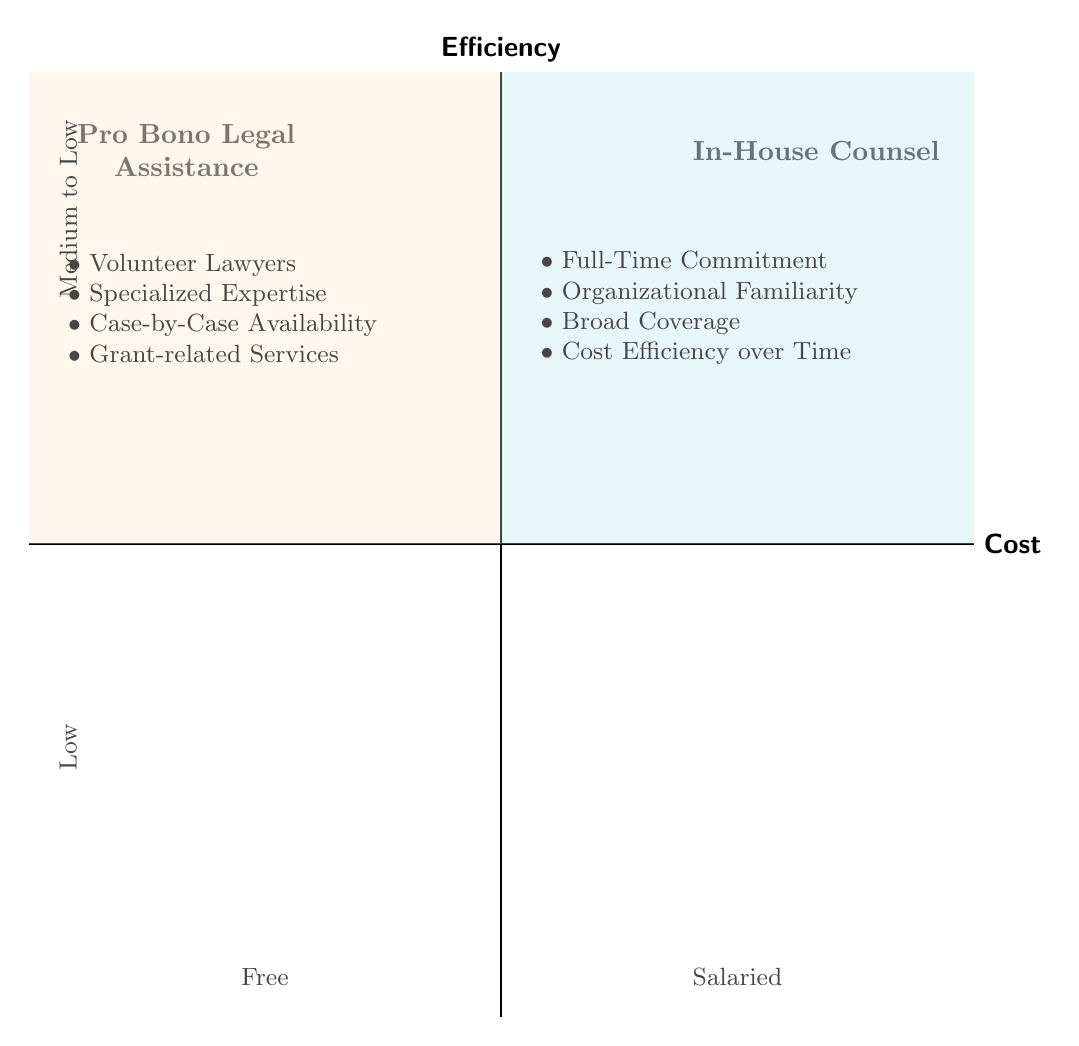What is the cost associated with Pro Bono Legal Assistance? The diagram indicates that the cost associated with Pro Bono Legal Assistance is "Free." This can be found in the quadrant labeled "Pro Bono Legal Assistance," specifically at the position where the vertical axis (Cost) is designated.
Answer: Free How many elements are listed under In-House Counsel? The diagram shows four elements listed under the "In-House Counsel" quadrant. I counted the bullet points, which directly represent each element in that section.
Answer: Four What type of Legal Assistance offers "Case-by-Case Availability"? "Case-by-Case Availability" is mentioned as an element in the "Pro Bono Legal Assistance" quadrant, specifically under its list of elements.
Answer: Pro Bono Legal Assistance Which quadrant is labeled "High" for Efficiency? The "In-House Counsel" quadrant is labeled "High" on the Efficiency axis at the top section of the diagram, indicating this quadrant's efficiency level.
Answer: In-House Counsel Which quadrant discusses "Cost Efficiency over Time"? The element "Cost Efficiency over Time" is listed in the "In-House Counsel" quadrant, making it clear that this aspect pertains to the In-House Counsel's efficiency related to costs.
Answer: In-House Counsel What is the relationship between "Organizational Familiarity" and "Efficiency"? "Organizational Familiarity" is part of the elements in the "In-House Counsel" quadrant, which is marked "High" for Efficiency. This indicates that it contributes positively to overall efficiency.
Answer: Positive How does the cost of Pro Bono compare to In-House Counsel? The cost of Pro Bono Legal Assistance is "Free," while the cost of In-House Counsel is marked as "Salaried." This comparison illustrates that Pro Bono is without direct cost, whereas In-House incurs a salary expense.
Answer: Pro Bono is Free; In-House Counsel is Salaried What describes the availability of Pro Bono Legal Assistance? The availability of Pro Bono Legal Assistance is described as "Case-by-Case Availability", indicating that the assistance is contingent on the volunteers' schedules and commitments.
Answer: Case-by-Case Availability Which element is related to specialized expertise in the Pro Bono quadrant? The element related to specialized expertise in the Pro Bono quadrant is "Specialized Expertise", indicating that it focuses on providing niche legal knowledge.
Answer: Specialized Expertise 